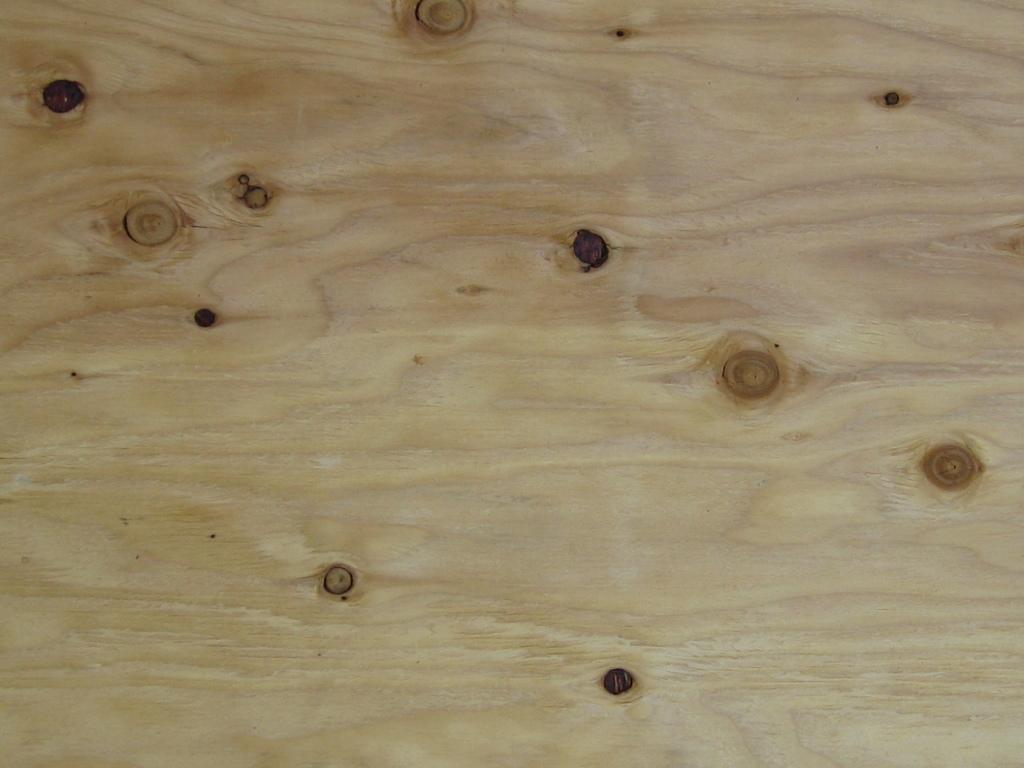What type of material is the main object in the image made of? The main object in the image is made of wood. Can you describe any specific features of the wooden object? Yes, the wooden object has marks on it. How does the insect interact with the icicle in the image? There is no insect or icicle present in the image; it only features a wooden object with marks on it. 